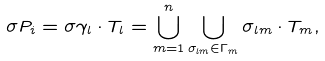<formula> <loc_0><loc_0><loc_500><loc_500>\sigma P _ { i } = \sigma \gamma _ { l } \cdot T _ { l } = \bigcup _ { m = 1 } ^ { n } \bigcup _ { \sigma _ { l m } \in \Gamma _ { m } } \sigma _ { l m } \cdot T _ { m } ,</formula> 